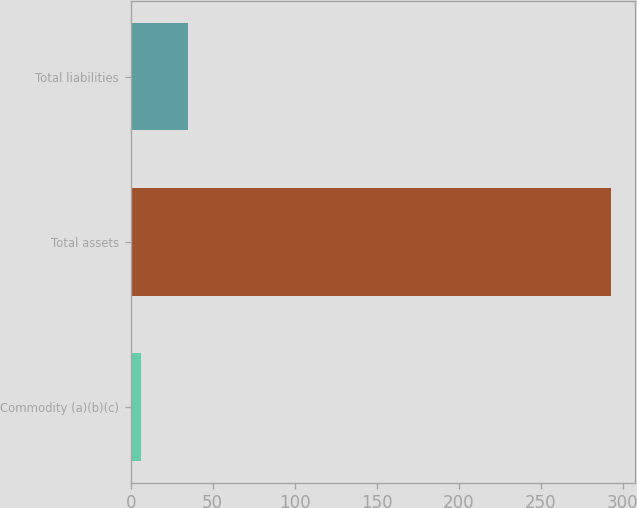Convert chart to OTSL. <chart><loc_0><loc_0><loc_500><loc_500><bar_chart><fcel>Commodity (a)(b)(c)<fcel>Total assets<fcel>Total liabilities<nl><fcel>6<fcel>293<fcel>34.7<nl></chart> 